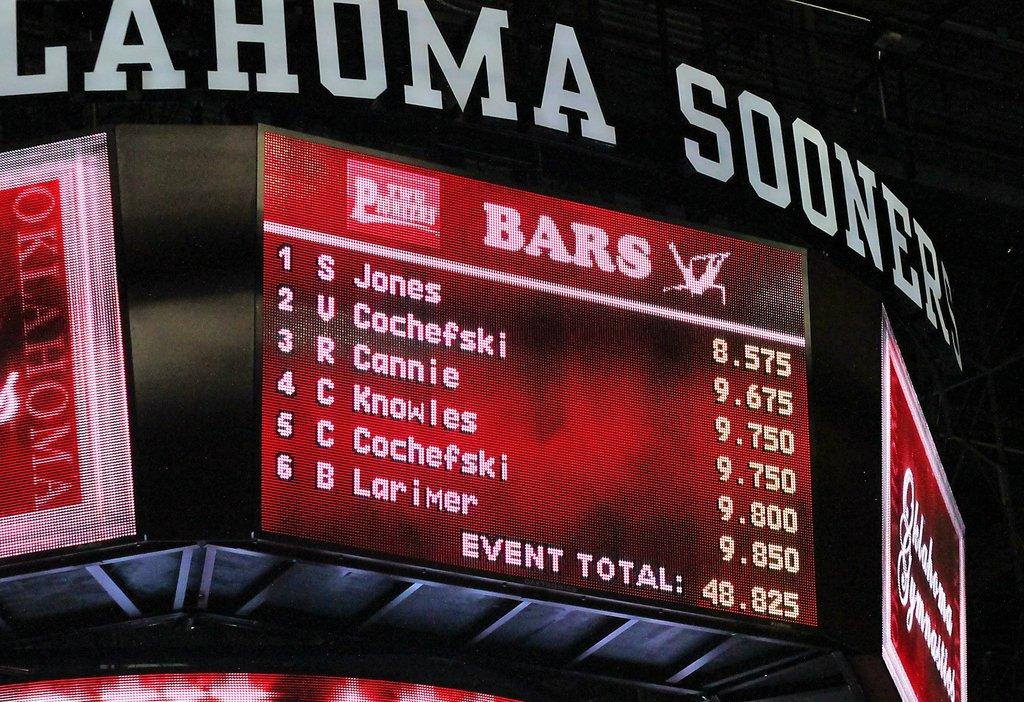<image>
Present a compact description of the photo's key features. An Oklahoma Sooners score board with results from six players. 